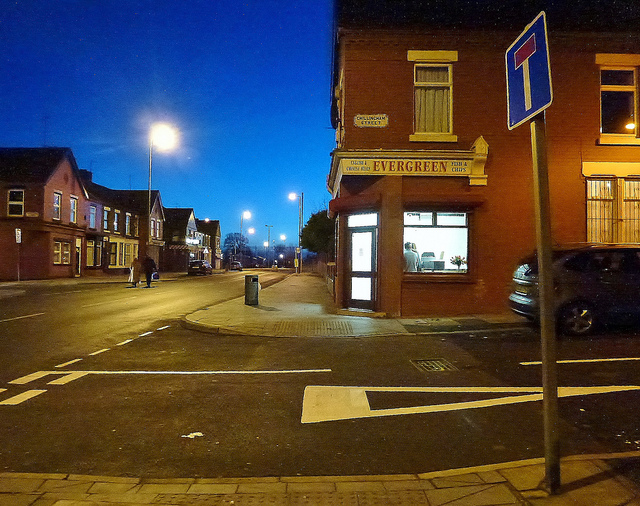<image>What symbol is on the closest sign? It is unclear what symbol is on the closest sign. It could be a 't' or a 'hammer'. What symbol is on the closest sign? I am not sure what symbol is on the closest sign. It can be seen 't' or something else. 